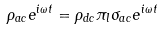Convert formula to latex. <formula><loc_0><loc_0><loc_500><loc_500>\rho _ { a c } e ^ { i \omega t } = \rho _ { d c } \pi _ { l } \sigma _ { a c } e ^ { i \omega t }</formula> 